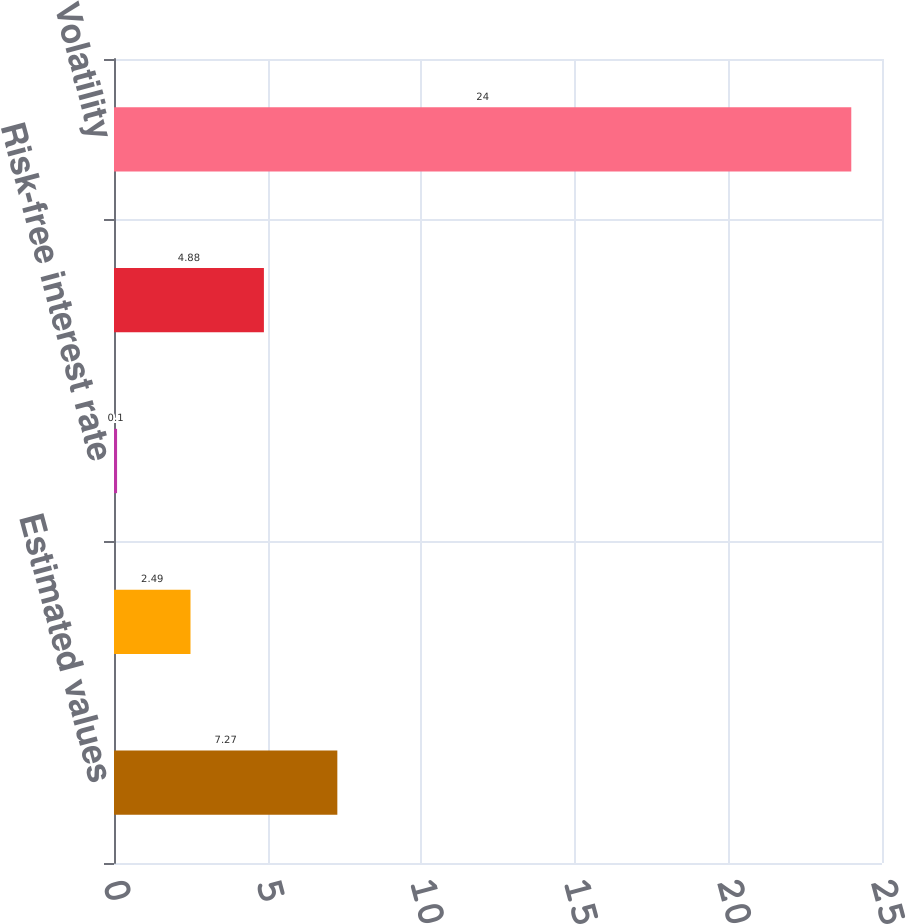Convert chart. <chart><loc_0><loc_0><loc_500><loc_500><bar_chart><fcel>Estimated values<fcel>Expected life (in years)<fcel>Risk-free interest rate<fcel>Dividend yield<fcel>Volatility<nl><fcel>7.27<fcel>2.49<fcel>0.1<fcel>4.88<fcel>24<nl></chart> 